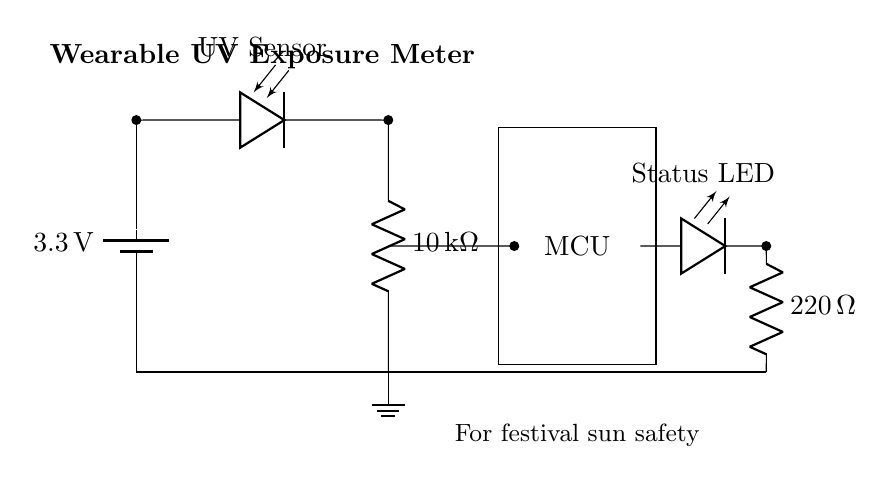What is the type of power source in this circuit? The circuit uses a battery, specifically a three-volt battery, as the power source. This can be identified from the component labeled as "battery" in the circuit diagram.
Answer: battery What is the resistance value of the photodiode? The photodiode does not have a specific resistance value listed; instead, it functions to detect UV light. Photodiodes are typically characterized by their response to light rather than having a conventional fixed resistance.
Answer: not applicable What is the resistance value of the resistor connected to the microcontroller? The resistor connected to the microcontroller is labeled as ten kilohms. This can be verified by looking at the label next to the resistor in the circuit diagram.
Answer: ten kilohms What does the status LED indicate? The status LED shows whether the circuit is actively monitoring UV exposure. Typically, it lights up when the circuit is functioning, indicating power and operational status. This can be inferred from its label "Status LED" in the diagram.
Answer: circuit status How many external components are connected to the microcontroller? There are two external components connected to the microcontroller: the photodiode and the resistor. The circuit diagram clearly shows that both components are linked to the MCU, making it easy to count.
Answer: two What is the purpose of the resistor connected to the LED? The purpose of the resistor connected to the LED is to limit current through the LED to prevent burnout. This is necessary for any LED in a circuit; the specific value is two hundred twenty ohms, as indicated by the label next to the resistor in the circuit.
Answer: limit current What is the voltage supplied by the battery? The battery supplies a voltage of three point three volts, which can be directly read from the label next to the battery in the circuit diagram.
Answer: three point three volts 